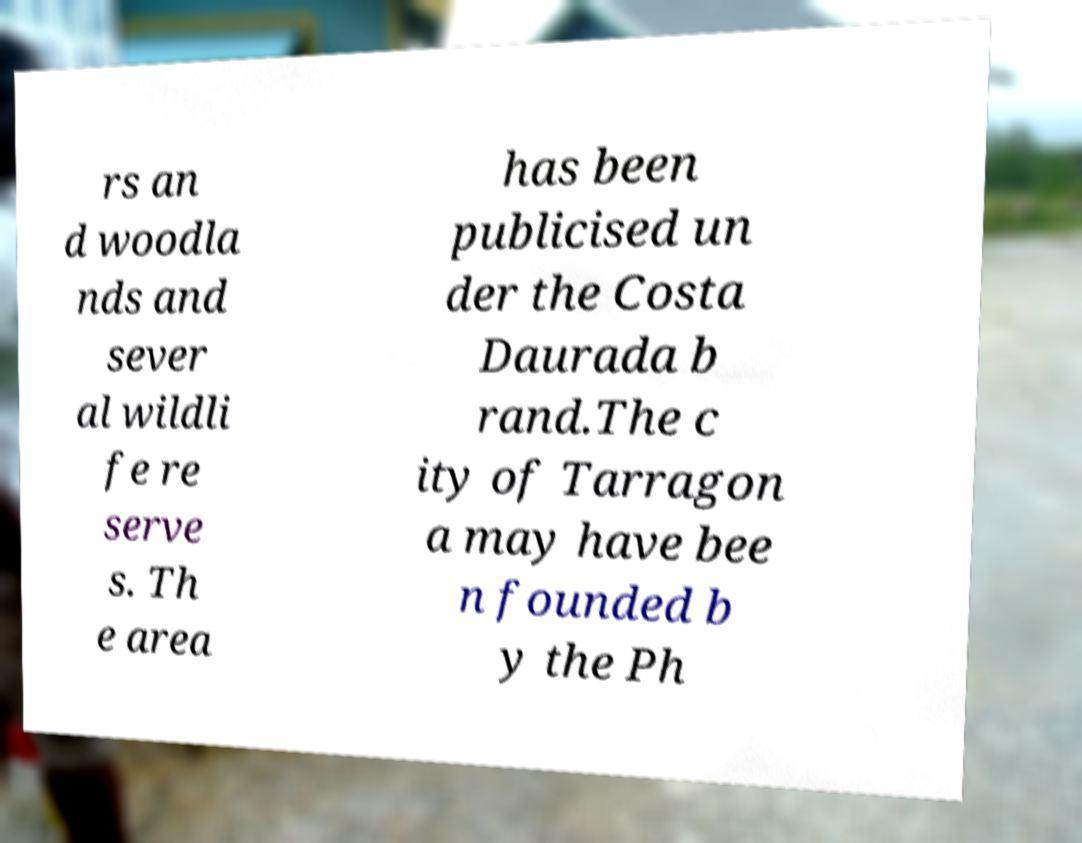I need the written content from this picture converted into text. Can you do that? rs an d woodla nds and sever al wildli fe re serve s. Th e area has been publicised un der the Costa Daurada b rand.The c ity of Tarragon a may have bee n founded b y the Ph 